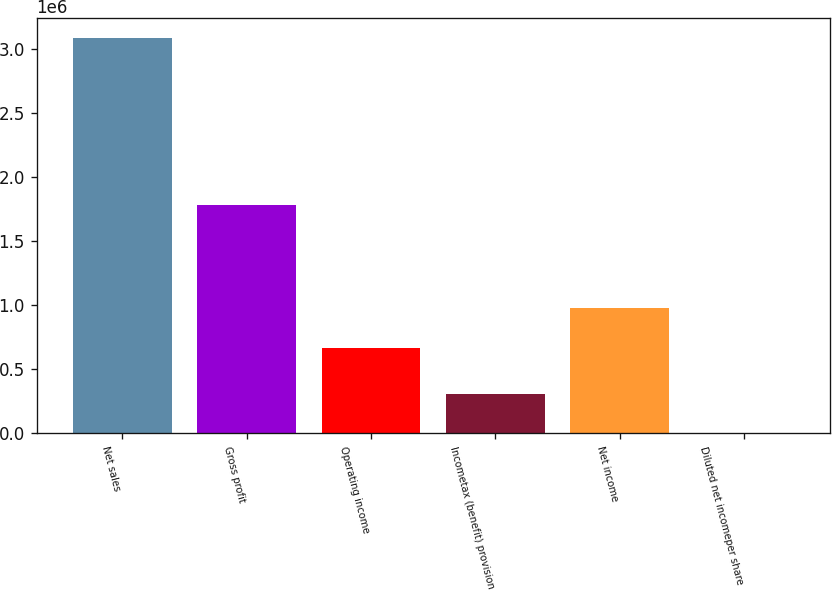Convert chart. <chart><loc_0><loc_0><loc_500><loc_500><bar_chart><fcel>Net sales<fcel>Gross profit<fcel>Operating income<fcel>Incometax (benefit) provision<fcel>Net income<fcel>Diluted net incomeper share<nl><fcel>3.087e+06<fcel>1.78316e+06<fcel>668860<fcel>308704<fcel>977560<fcel>3.68<nl></chart> 